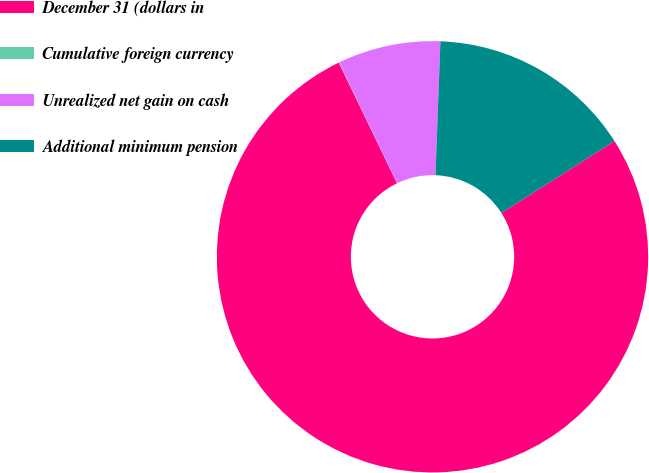<chart> <loc_0><loc_0><loc_500><loc_500><pie_chart><fcel>December 31 (dollars in<fcel>Cumulative foreign currency<fcel>Unrealized net gain on cash<fcel>Additional minimum pension<nl><fcel>76.86%<fcel>0.03%<fcel>7.71%<fcel>15.4%<nl></chart> 